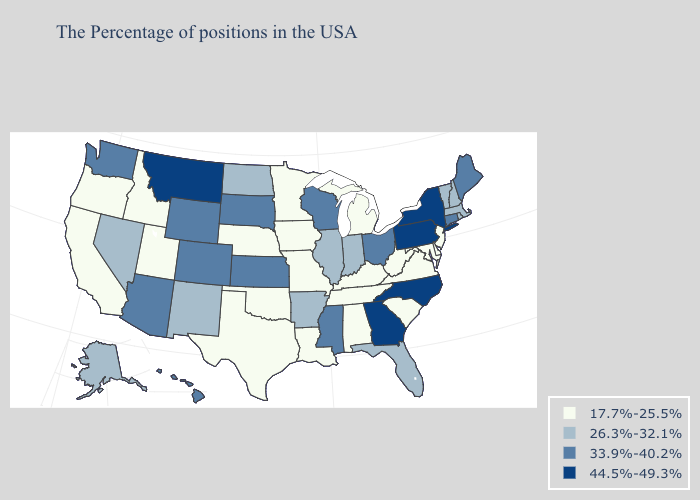Does Minnesota have the lowest value in the MidWest?
Concise answer only. Yes. Name the states that have a value in the range 33.9%-40.2%?
Keep it brief. Maine, Connecticut, Ohio, Wisconsin, Mississippi, Kansas, South Dakota, Wyoming, Colorado, Arizona, Washington, Hawaii. What is the highest value in the South ?
Be succinct. 44.5%-49.3%. Which states hav the highest value in the South?
Be succinct. North Carolina, Georgia. Does Pennsylvania have the highest value in the Northeast?
Keep it brief. Yes. Among the states that border Vermont , does New Hampshire have the lowest value?
Write a very short answer. Yes. What is the value of North Dakota?
Quick response, please. 26.3%-32.1%. Among the states that border Kentucky , which have the lowest value?
Write a very short answer. Virginia, West Virginia, Tennessee, Missouri. Name the states that have a value in the range 26.3%-32.1%?
Quick response, please. Massachusetts, Rhode Island, New Hampshire, Vermont, Florida, Indiana, Illinois, Arkansas, North Dakota, New Mexico, Nevada, Alaska. Name the states that have a value in the range 33.9%-40.2%?
Short answer required. Maine, Connecticut, Ohio, Wisconsin, Mississippi, Kansas, South Dakota, Wyoming, Colorado, Arizona, Washington, Hawaii. Does the map have missing data?
Quick response, please. No. Does West Virginia have the same value as Indiana?
Short answer required. No. What is the highest value in states that border Georgia?
Short answer required. 44.5%-49.3%. What is the value of Utah?
Quick response, please. 17.7%-25.5%. What is the highest value in the USA?
Concise answer only. 44.5%-49.3%. 